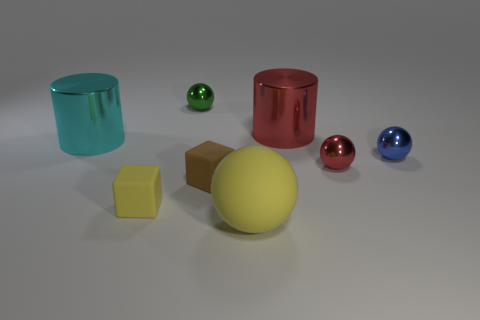What color is the large object that is right of the small yellow object and behind the small blue ball?
Give a very brief answer. Red. Is there a tiny cyan ball that has the same material as the brown thing?
Ensure brevity in your answer.  No. How big is the red cylinder?
Make the answer very short. Large. There is a shiny sphere that is behind the big object that is behind the cyan metal cylinder; what size is it?
Offer a very short reply. Small. There is a yellow thing that is the same shape as the tiny green metallic thing; what is its material?
Your response must be concise. Rubber. What number of tiny green metallic cylinders are there?
Give a very brief answer. 0. What color is the sphere that is behind the large metal object right of the tiny metallic ball behind the tiny blue metal object?
Make the answer very short. Green. Are there fewer big cyan objects than small brown metal objects?
Keep it short and to the point. No. There is a large matte thing that is the same shape as the small red metal thing; what color is it?
Your answer should be compact. Yellow. What is the color of the other cylinder that is made of the same material as the big red cylinder?
Offer a terse response. Cyan. 